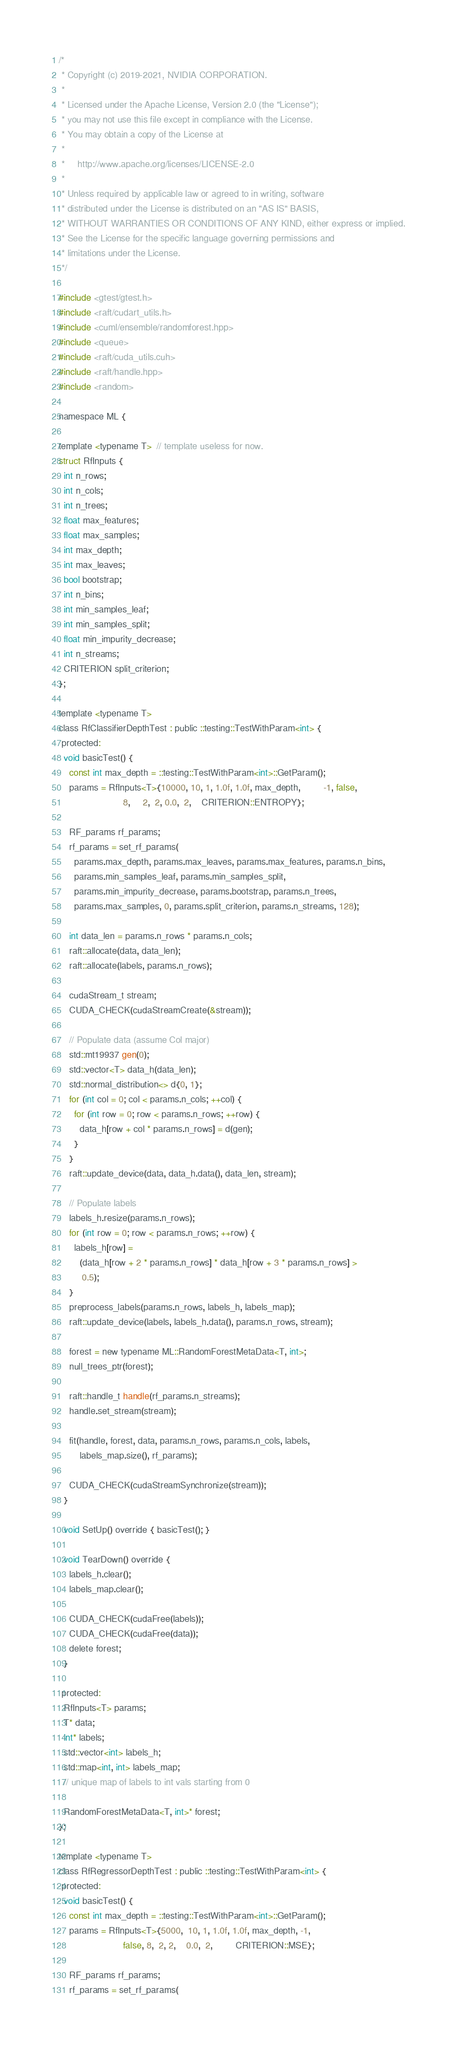<code> <loc_0><loc_0><loc_500><loc_500><_Cuda_>/*
 * Copyright (c) 2019-2021, NVIDIA CORPORATION.
 *
 * Licensed under the Apache License, Version 2.0 (the "License");
 * you may not use this file except in compliance with the License.
 * You may obtain a copy of the License at
 *
 *     http://www.apache.org/licenses/LICENSE-2.0
 *
 * Unless required by applicable law or agreed to in writing, software
 * distributed under the License is distributed on an "AS IS" BASIS,
 * WITHOUT WARRANTIES OR CONDITIONS OF ANY KIND, either express or implied.
 * See the License for the specific language governing permissions and
 * limitations under the License.
 */

#include <gtest/gtest.h>
#include <raft/cudart_utils.h>
#include <cuml/ensemble/randomforest.hpp>
#include <queue>
#include <raft/cuda_utils.cuh>
#include <raft/handle.hpp>
#include <random>

namespace ML {

template <typename T>  // template useless for now.
struct RfInputs {
  int n_rows;
  int n_cols;
  int n_trees;
  float max_features;
  float max_samples;
  int max_depth;
  int max_leaves;
  bool bootstrap;
  int n_bins;
  int min_samples_leaf;
  int min_samples_split;
  float min_impurity_decrease;
  int n_streams;
  CRITERION split_criterion;
};

template <typename T>
class RfClassifierDepthTest : public ::testing::TestWithParam<int> {
 protected:
  void basicTest() {
    const int max_depth = ::testing::TestWithParam<int>::GetParam();
    params = RfInputs<T>{10000, 10, 1, 1.0f, 1.0f, max_depth,         -1, false,
                         8,     2,  2, 0.0,  2,    CRITERION::ENTROPY};

    RF_params rf_params;
    rf_params = set_rf_params(
      params.max_depth, params.max_leaves, params.max_features, params.n_bins,
      params.min_samples_leaf, params.min_samples_split,
      params.min_impurity_decrease, params.bootstrap, params.n_trees,
      params.max_samples, 0, params.split_criterion, params.n_streams, 128);

    int data_len = params.n_rows * params.n_cols;
    raft::allocate(data, data_len);
    raft::allocate(labels, params.n_rows);

    cudaStream_t stream;
    CUDA_CHECK(cudaStreamCreate(&stream));

    // Populate data (assume Col major)
    std::mt19937 gen(0);
    std::vector<T> data_h(data_len);
    std::normal_distribution<> d{0, 1};
    for (int col = 0; col < params.n_cols; ++col) {
      for (int row = 0; row < params.n_rows; ++row) {
        data_h[row + col * params.n_rows] = d(gen);
      }
    }
    raft::update_device(data, data_h.data(), data_len, stream);

    // Populate labels
    labels_h.resize(params.n_rows);
    for (int row = 0; row < params.n_rows; ++row) {
      labels_h[row] =
        (data_h[row + 2 * params.n_rows] * data_h[row + 3 * params.n_rows] >
         0.5);
    }
    preprocess_labels(params.n_rows, labels_h, labels_map);
    raft::update_device(labels, labels_h.data(), params.n_rows, stream);

    forest = new typename ML::RandomForestMetaData<T, int>;
    null_trees_ptr(forest);

    raft::handle_t handle(rf_params.n_streams);
    handle.set_stream(stream);

    fit(handle, forest, data, params.n_rows, params.n_cols, labels,
        labels_map.size(), rf_params);

    CUDA_CHECK(cudaStreamSynchronize(stream));
  }

  void SetUp() override { basicTest(); }

  void TearDown() override {
    labels_h.clear();
    labels_map.clear();

    CUDA_CHECK(cudaFree(labels));
    CUDA_CHECK(cudaFree(data));
    delete forest;
  }

 protected:
  RfInputs<T> params;
  T* data;
  int* labels;
  std::vector<int> labels_h;
  std::map<int, int> labels_map;
  // unique map of labels to int vals starting from 0

  RandomForestMetaData<T, int>* forest;
};

template <typename T>
class RfRegressorDepthTest : public ::testing::TestWithParam<int> {
 protected:
  void basicTest() {
    const int max_depth = ::testing::TestWithParam<int>::GetParam();
    params = RfInputs<T>{5000,  10, 1, 1.0f, 1.0f, max_depth, -1,
                         false, 8,  2, 2,    0.0,  2,         CRITERION::MSE};

    RF_params rf_params;
    rf_params = set_rf_params(</code> 